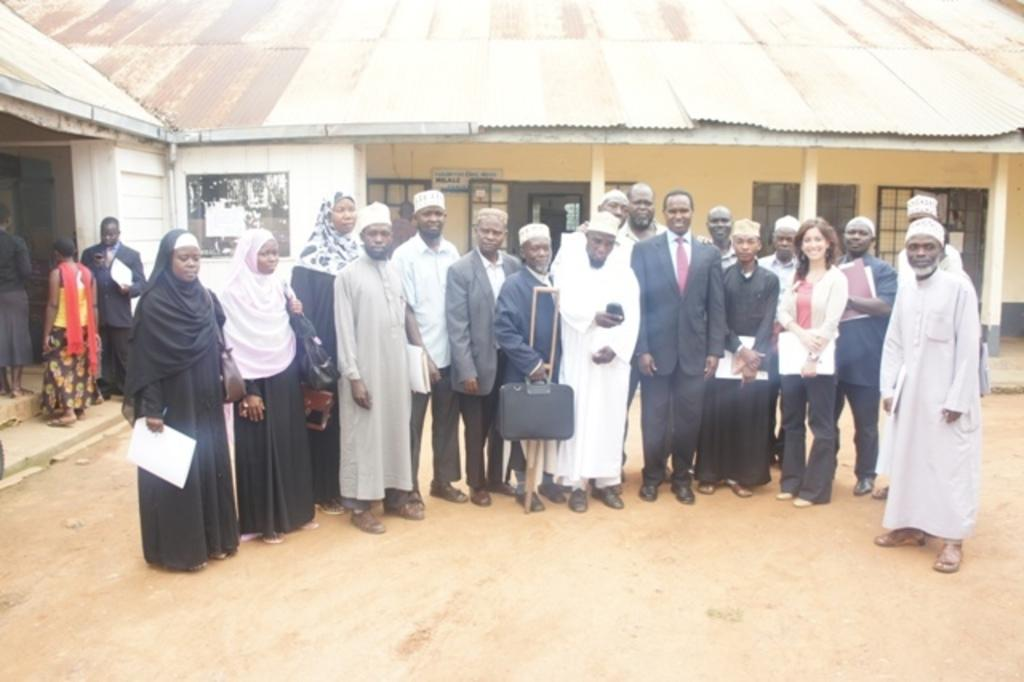What is happening in the middle of the picture? There are people standing on the land in the middle of the picture. Can you describe the gender of the people in the picture? There are men and women in the picture. What can be seen in the background of the picture? There is a house in the background of the picture. What level of experience do the people in the picture have with hearing? There is no information about the people's experience with hearing in the image, so it cannot be determined. 